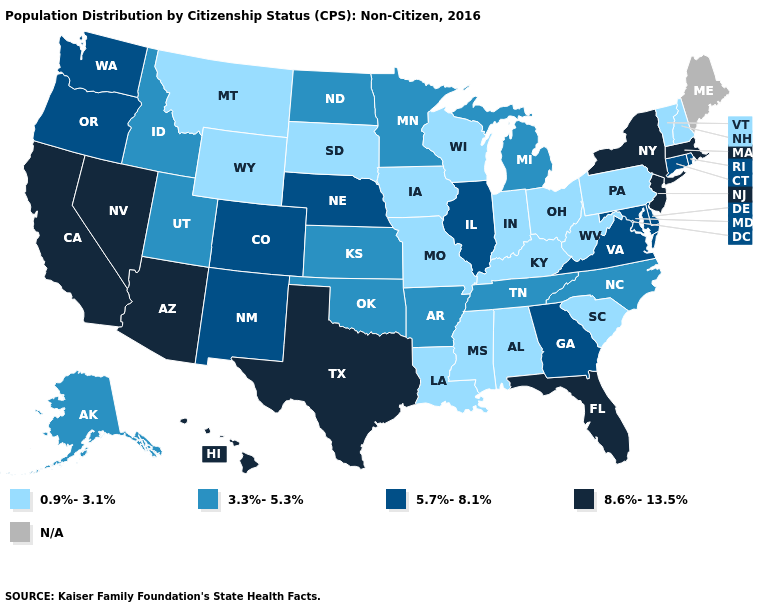What is the value of Hawaii?
Be succinct. 8.6%-13.5%. Name the states that have a value in the range 3.3%-5.3%?
Short answer required. Alaska, Arkansas, Idaho, Kansas, Michigan, Minnesota, North Carolina, North Dakota, Oklahoma, Tennessee, Utah. What is the value of Massachusetts?
Keep it brief. 8.6%-13.5%. What is the lowest value in the USA?
Keep it brief. 0.9%-3.1%. What is the value of New Mexico?
Write a very short answer. 5.7%-8.1%. Which states have the lowest value in the USA?
Concise answer only. Alabama, Indiana, Iowa, Kentucky, Louisiana, Mississippi, Missouri, Montana, New Hampshire, Ohio, Pennsylvania, South Carolina, South Dakota, Vermont, West Virginia, Wisconsin, Wyoming. What is the value of New Mexico?
Short answer required. 5.7%-8.1%. Does the map have missing data?
Concise answer only. Yes. Does the map have missing data?
Answer briefly. Yes. Name the states that have a value in the range 0.9%-3.1%?
Concise answer only. Alabama, Indiana, Iowa, Kentucky, Louisiana, Mississippi, Missouri, Montana, New Hampshire, Ohio, Pennsylvania, South Carolina, South Dakota, Vermont, West Virginia, Wisconsin, Wyoming. Which states have the highest value in the USA?
Give a very brief answer. Arizona, California, Florida, Hawaii, Massachusetts, Nevada, New Jersey, New York, Texas. What is the value of Arizona?
Be succinct. 8.6%-13.5%. 